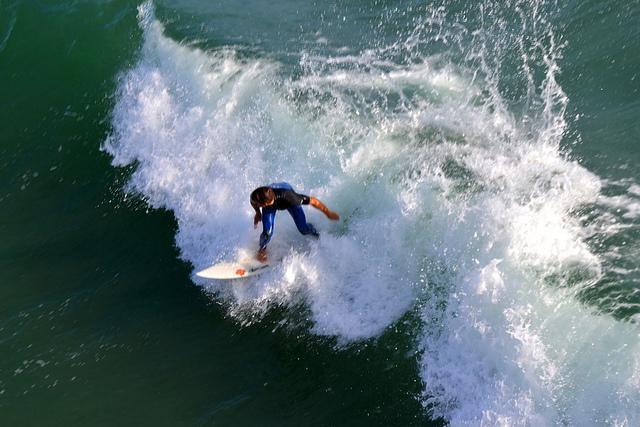How many white remotes do you see?
Give a very brief answer. 0. 